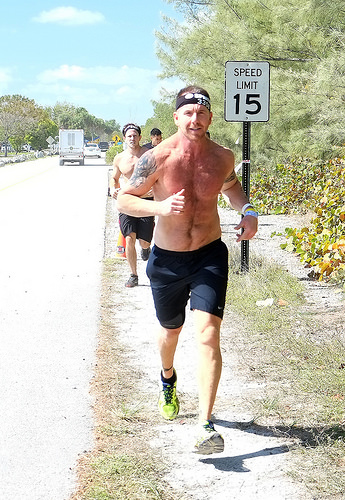<image>
Is there a man on the ground? Yes. Looking at the image, I can see the man is positioned on top of the ground, with the ground providing support. Is there a truck next to the person? No. The truck is not positioned next to the person. They are located in different areas of the scene. 